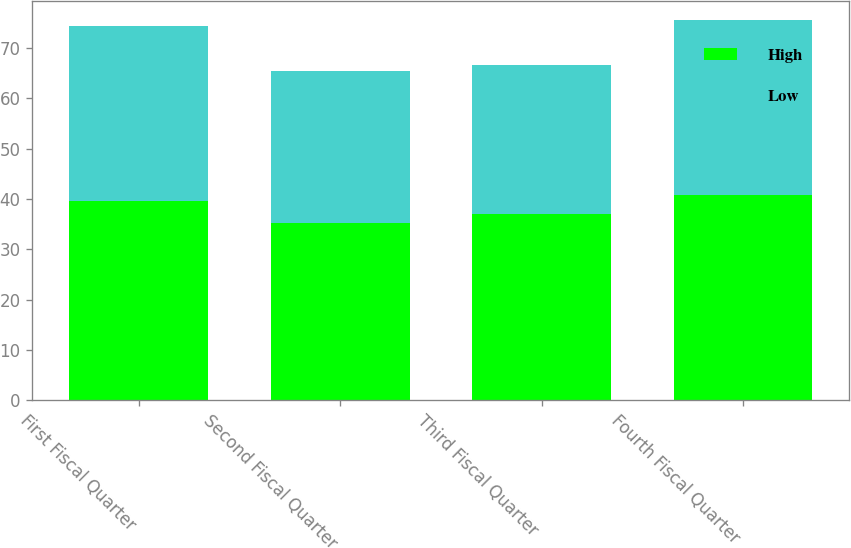Convert chart to OTSL. <chart><loc_0><loc_0><loc_500><loc_500><stacked_bar_chart><ecel><fcel>First Fiscal Quarter<fcel>Second Fiscal Quarter<fcel>Third Fiscal Quarter<fcel>Fourth Fiscal Quarter<nl><fcel>High<fcel>39.5<fcel>35.31<fcel>36.95<fcel>40.8<nl><fcel>Low<fcel>34.77<fcel>30.11<fcel>29.63<fcel>34.71<nl></chart> 